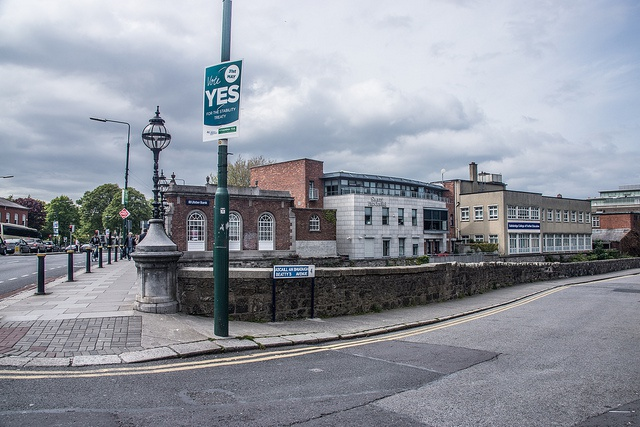Describe the objects in this image and their specific colors. I can see bus in lavender, black, darkgray, and gray tones, car in lavender, gray, black, darkgray, and lightgray tones, car in lavender, gray, black, and darkgray tones, people in lavender, black, gray, and navy tones, and people in lavender, black, gray, and blue tones in this image. 